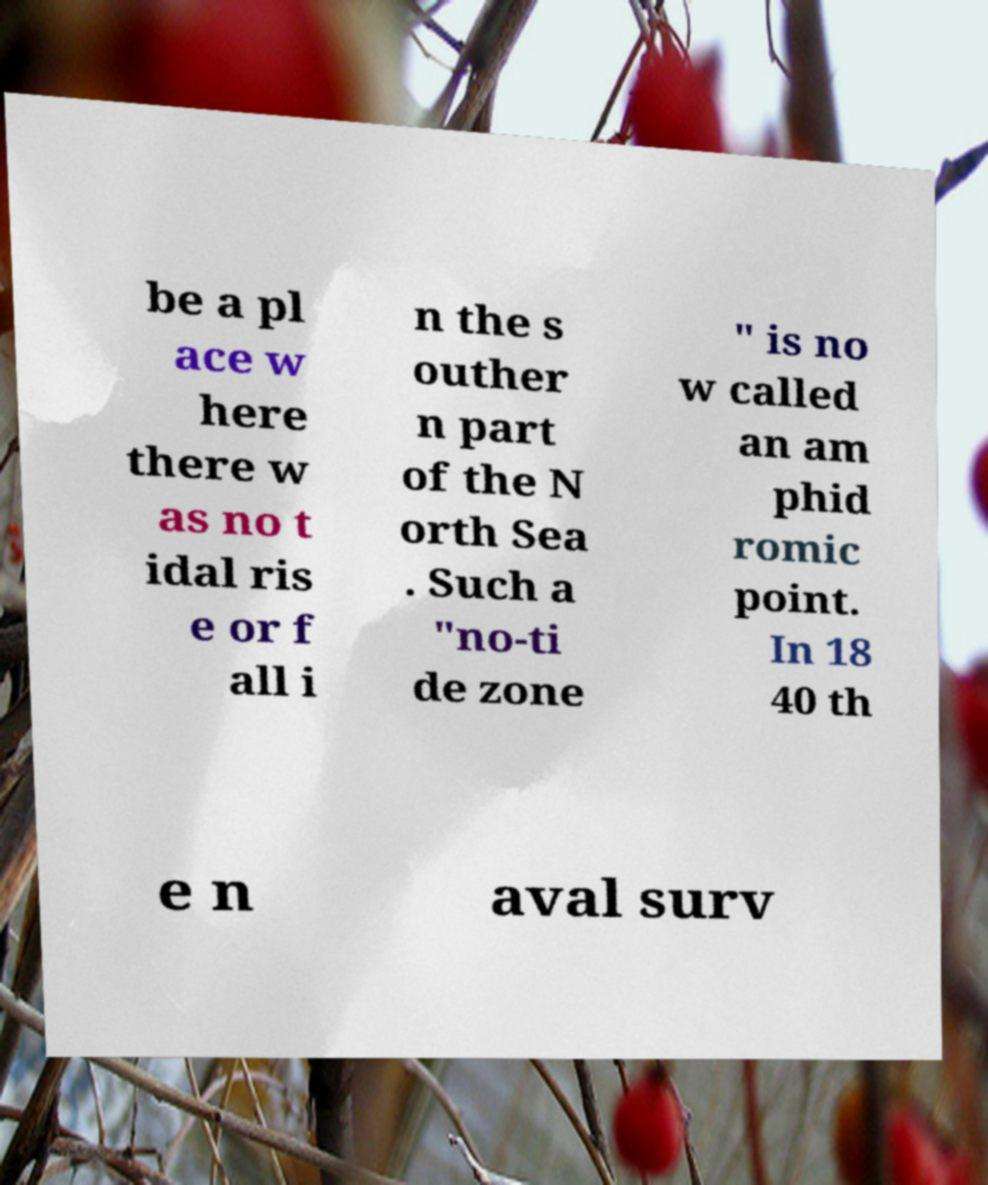Please read and relay the text visible in this image. What does it say? be a pl ace w here there w as no t idal ris e or f all i n the s outher n part of the N orth Sea . Such a "no-ti de zone " is no w called an am phid romic point. In 18 40 th e n aval surv 